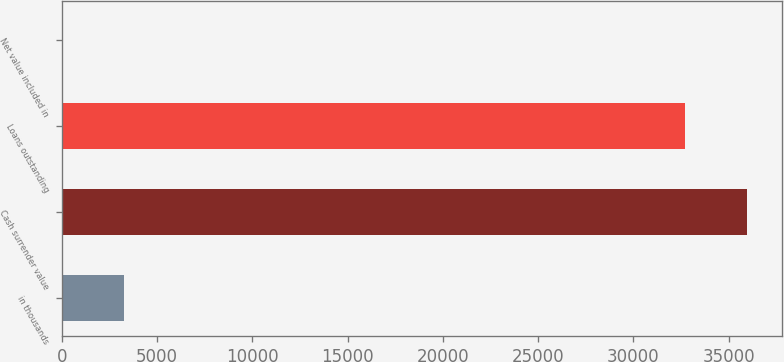Convert chart. <chart><loc_0><loc_0><loc_500><loc_500><bar_chart><fcel>in thousands<fcel>Cash surrender value<fcel>Loans outstanding<fcel>Net value included in<nl><fcel>3281<fcel>35981<fcel>32710<fcel>10<nl></chart> 